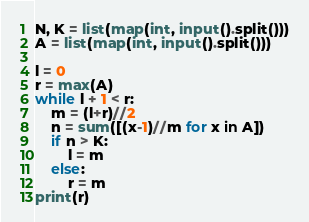<code> <loc_0><loc_0><loc_500><loc_500><_Python_>N, K = list(map(int, input().split()))
A = list(map(int, input().split()))

l = 0
r = max(A)
while l + 1 < r:
    m = (l+r)//2
    n = sum([(x-1)//m for x in A])
    if n > K:
        l = m
    else:
        r = m
print(r)</code> 